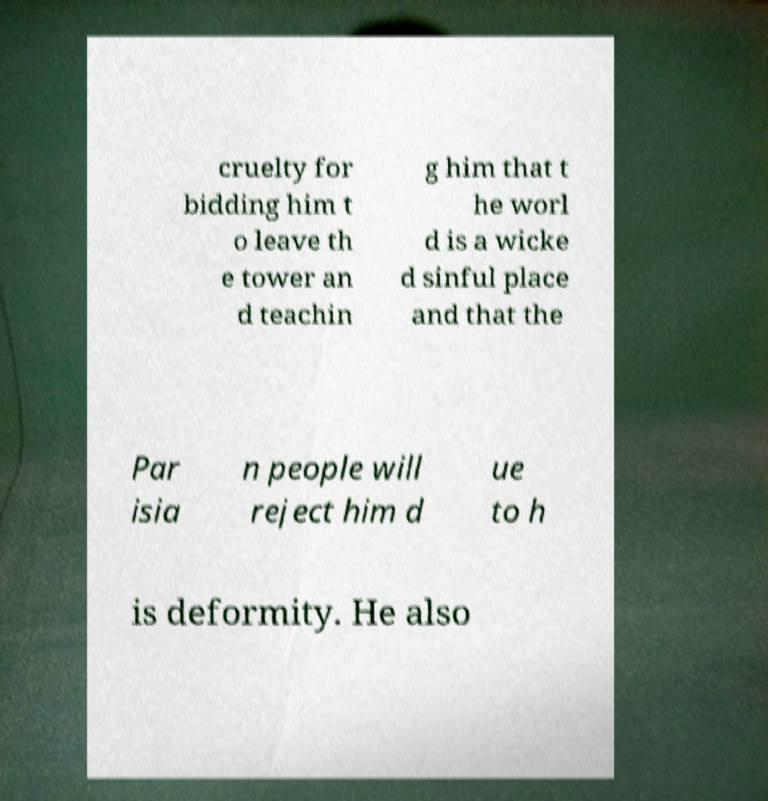For documentation purposes, I need the text within this image transcribed. Could you provide that? cruelty for bidding him t o leave th e tower an d teachin g him that t he worl d is a wicke d sinful place and that the Par isia n people will reject him d ue to h is deformity. He also 